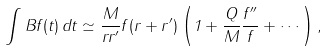Convert formula to latex. <formula><loc_0><loc_0><loc_500><loc_500>\int B f ( t ) \, d t \simeq \frac { M } { r r ^ { \prime } } f ( r + r ^ { \prime } ) \left ( 1 + \frac { Q } { M } \frac { f ^ { \prime \prime } } { f } + \cdots \right ) ,</formula> 